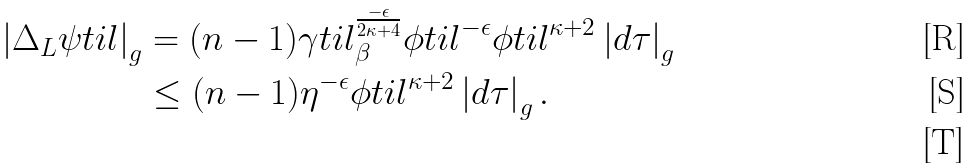<formula> <loc_0><loc_0><loc_500><loc_500>\left | \Delta _ { L } \psi t i l \right | _ { g } & = ( n - 1 ) \gamma t i l _ { \beta } ^ { \frac { - \epsilon } { 2 \kappa + 4 } } \phi t i l ^ { - \epsilon } \phi t i l ^ { \kappa + 2 } \left | d \tau \right | _ { g } \\ & \leq ( n - 1 ) \eta ^ { - \epsilon } \phi t i l ^ { \kappa + 2 } \left | d \tau \right | _ { g } . \\</formula> 